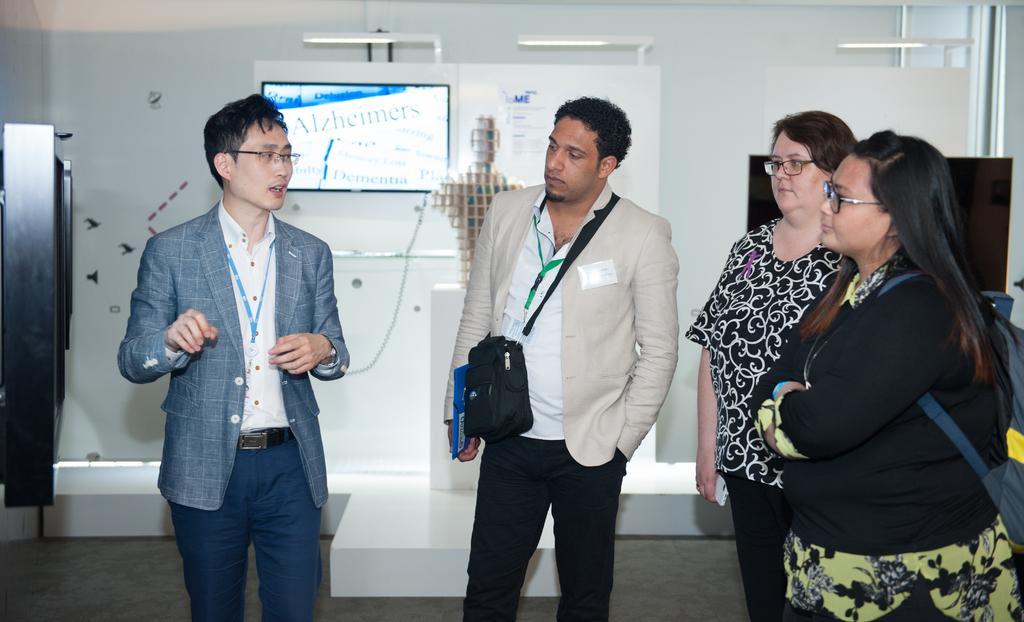How would you summarize this image in a sentence or two? In this picture we can see a few people standing and wearing bags. We can see a man holding an object in his hand. There is the text visible and a few things visible on the screen. We can see the lights and other objects. 